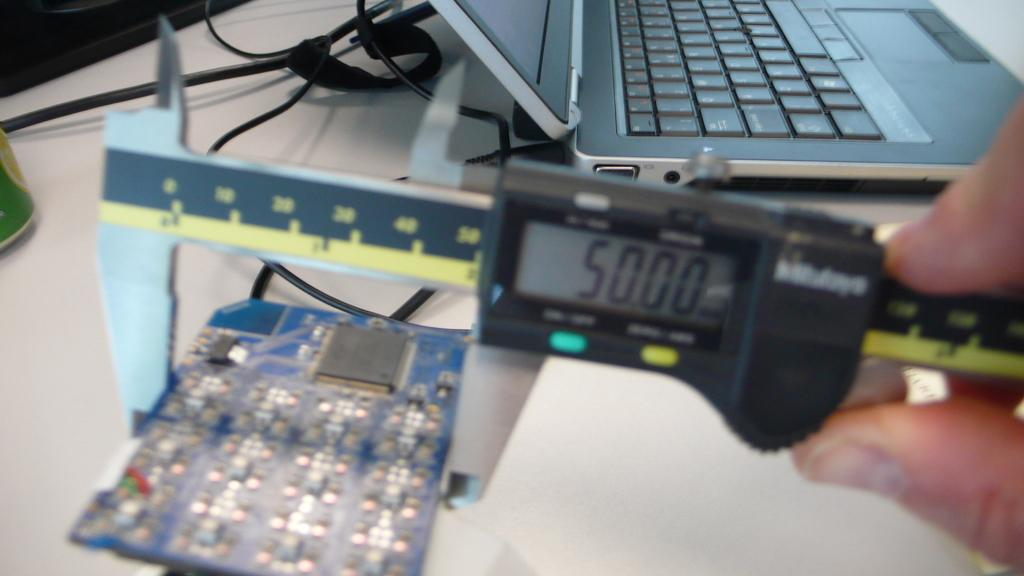<image>
Create a compact narrative representing the image presented. A measuring device has an LCD screen that reads 50.00 